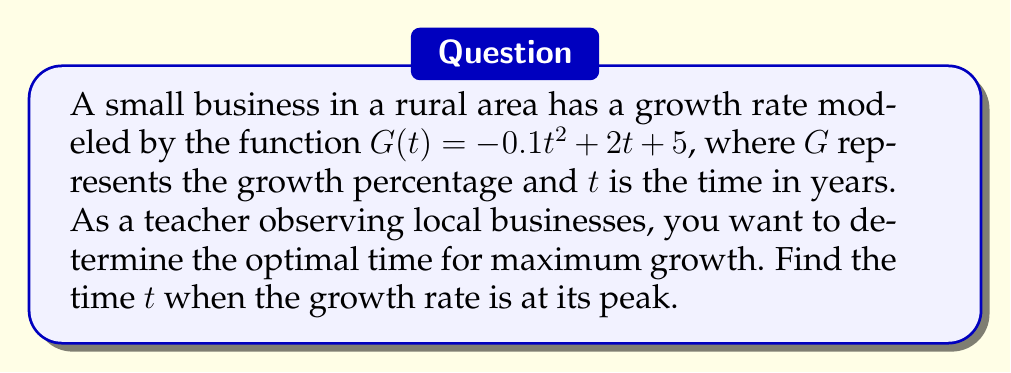Solve this math problem. To find the optimal time for maximum growth, we need to find the maximum point of the function $G(t)$. This can be done by following these steps:

1) First, we need to find the derivative of $G(t)$:
   $$G'(t) = -0.2t + 2$$

2) To find the maximum point, we set the derivative equal to zero and solve for $t$:
   $$-0.2t + 2 = 0$$
   $$-0.2t = -2$$
   $$t = 10$$

3) To confirm this is a maximum (not a minimum), we can check the second derivative:
   $$G''(t) = -0.2$$
   Since $G''(t)$ is negative, this confirms we have a maximum at $t = 10$.

4) Therefore, the growth rate reaches its peak after 10 years.

This solution shows that the small business will experience its optimal growth rate after a decade, which is valuable information for long-term planning in a rural area.
Answer: $t = 10$ years 